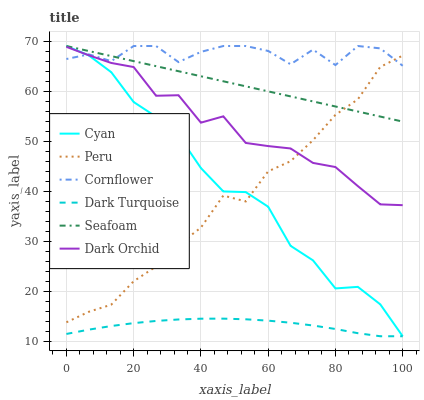Does Dark Turquoise have the minimum area under the curve?
Answer yes or no. Yes. Does Cornflower have the maximum area under the curve?
Answer yes or no. Yes. Does Seafoam have the minimum area under the curve?
Answer yes or no. No. Does Seafoam have the maximum area under the curve?
Answer yes or no. No. Is Seafoam the smoothest?
Answer yes or no. Yes. Is Cornflower the roughest?
Answer yes or no. Yes. Is Dark Turquoise the smoothest?
Answer yes or no. No. Is Dark Turquoise the roughest?
Answer yes or no. No. Does Dark Turquoise have the lowest value?
Answer yes or no. Yes. Does Seafoam have the lowest value?
Answer yes or no. No. Does Cyan have the highest value?
Answer yes or no. Yes. Does Dark Turquoise have the highest value?
Answer yes or no. No. Is Dark Turquoise less than Dark Orchid?
Answer yes or no. Yes. Is Peru greater than Dark Turquoise?
Answer yes or no. Yes. Does Cyan intersect Dark Turquoise?
Answer yes or no. Yes. Is Cyan less than Dark Turquoise?
Answer yes or no. No. Is Cyan greater than Dark Turquoise?
Answer yes or no. No. Does Dark Turquoise intersect Dark Orchid?
Answer yes or no. No. 